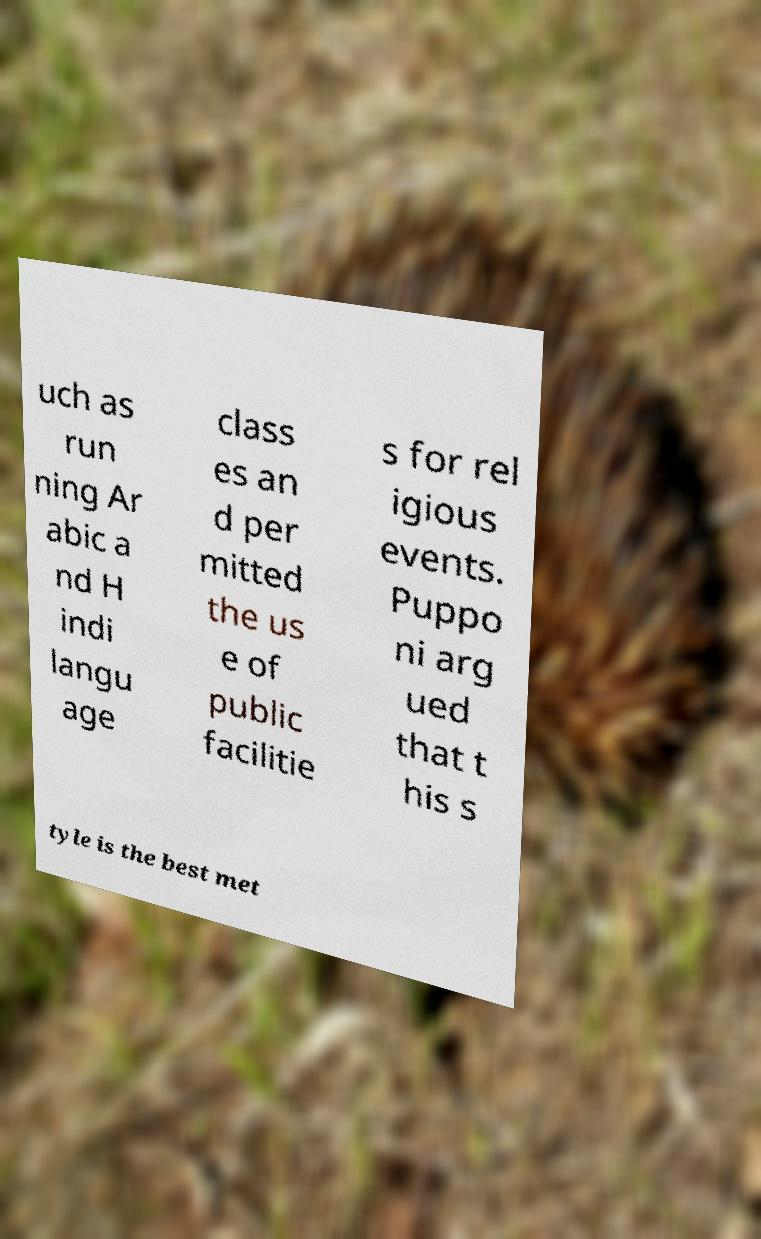Can you accurately transcribe the text from the provided image for me? uch as run ning Ar abic a nd H indi langu age class es an d per mitted the us e of public facilitie s for rel igious events. Puppo ni arg ued that t his s tyle is the best met 